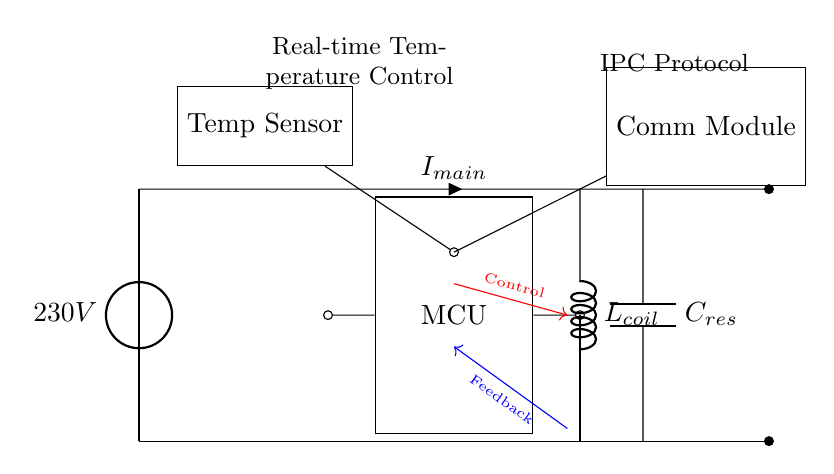What is the voltage supplied to the circuit? The voltage source is labeled as 230V in the diagram, indicating the supplied voltage to the circuit.
Answer: 230V What component is used for real-time temperature sensing? The diagram shows a "Temp Sensor" labeled as such, indicating its role in temperature measurements for control purposes.
Answer: Temp Sensor What type of control component is used in this circuit? The circuit features a microcontroller (MCU), which is a critical component for processing the control signals based on temperature feedback.
Answer: MCU How does the induction coil connect to the power source? The induction coil connects to the power line at the top, receiving current from the main power line and converting energy to heat as per the cooking requirement.
Answer: Inductor Which module handles interprocess communication? The circuit includes a "Comm Module," indicating that this component is responsible for communication protocols, likely for sending and receiving data related to the cooktop's operation.
Answer: Comm Module What type of transistor is used for switching in this circuit? The circuit diagram includes a labeled "IGBT" (Insulated Gate Bipolar Transistor), which is commonly used for high power switching applications in induction cooktops.
Answer: IGBT What is the role of the resonant capacitor? The "C_res" labeled component is the resonant capacitor, which is used for tuning the circuit to achieve efficient energy transfer in the induction process.
Answer: C_res 